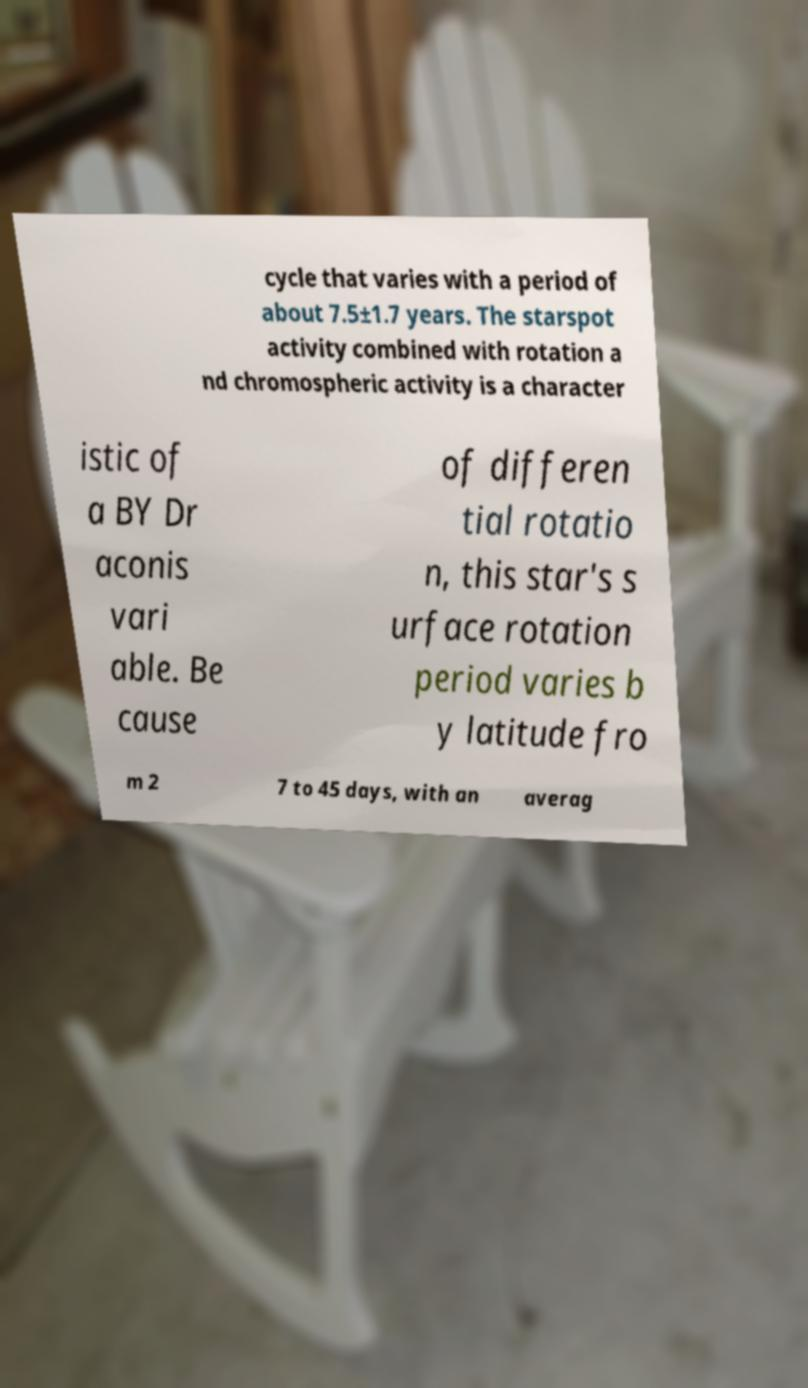Can you read and provide the text displayed in the image?This photo seems to have some interesting text. Can you extract and type it out for me? cycle that varies with a period of about 7.5±1.7 years. The starspot activity combined with rotation a nd chromospheric activity is a character istic of a BY Dr aconis vari able. Be cause of differen tial rotatio n, this star's s urface rotation period varies b y latitude fro m 2 7 to 45 days, with an averag 